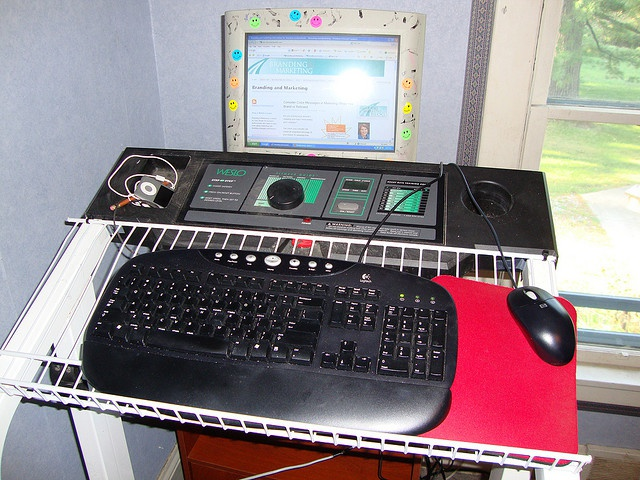Describe the objects in this image and their specific colors. I can see keyboard in darkgray, black, gray, and lightgray tones, tv in darkgray, lightgray, and lightblue tones, and mouse in darkgray, black, maroon, and gray tones in this image. 